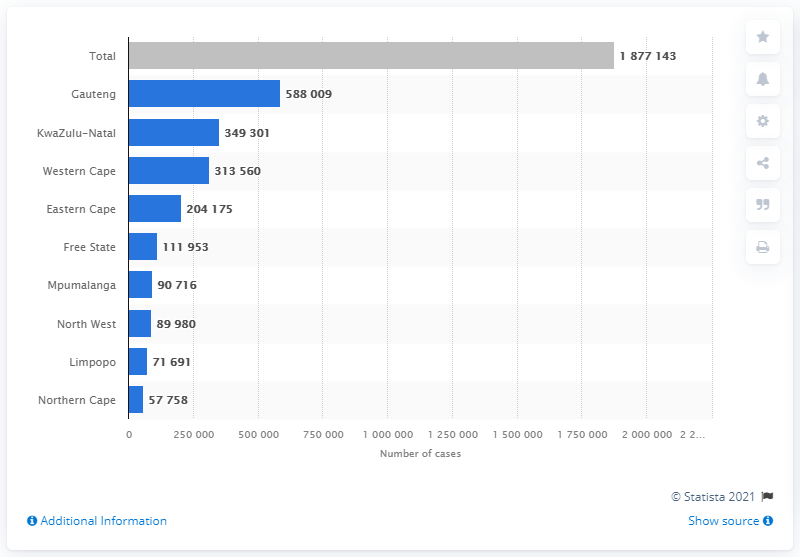List a handful of essential elements in this visual. Gauteng has the highest number of COVID-19 cases in the city. The city in the Northern Cape that has the least cases of [disease/crime/problem] is [city name]. 